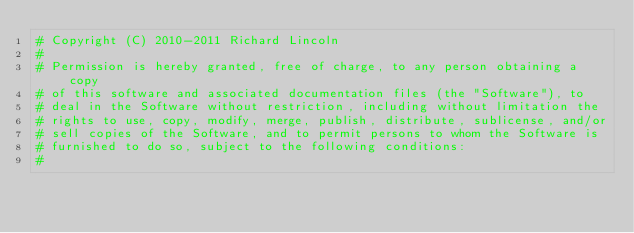Convert code to text. <code><loc_0><loc_0><loc_500><loc_500><_Python_># Copyright (C) 2010-2011 Richard Lincoln
#
# Permission is hereby granted, free of charge, to any person obtaining a copy
# of this software and associated documentation files (the "Software"), to
# deal in the Software without restriction, including without limitation the
# rights to use, copy, modify, merge, publish, distribute, sublicense, and/or
# sell copies of the Software, and to permit persons to whom the Software is
# furnished to do so, subject to the following conditions:
#</code> 